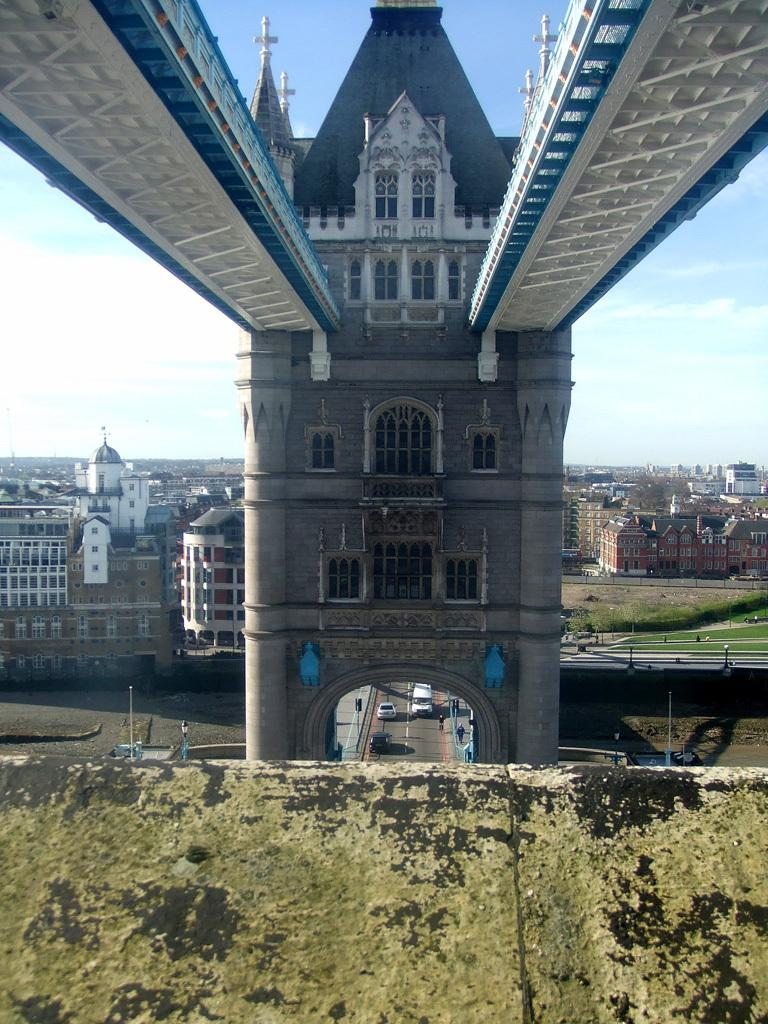What is located at the bottom of the image? There is a platform at the bottom of the image. What can be seen in the background of the image? There are two bridges, buildings, windows, vehicles on the road, poles, and grass visible in the background of the image. What is visible elements are present in the sky in the background of the image? There are clouds in the sky in the background of the image. What type of match is being played on the platform in the image? There is no match or game being played on the platform in the image; it is a platform without any visible activity. 